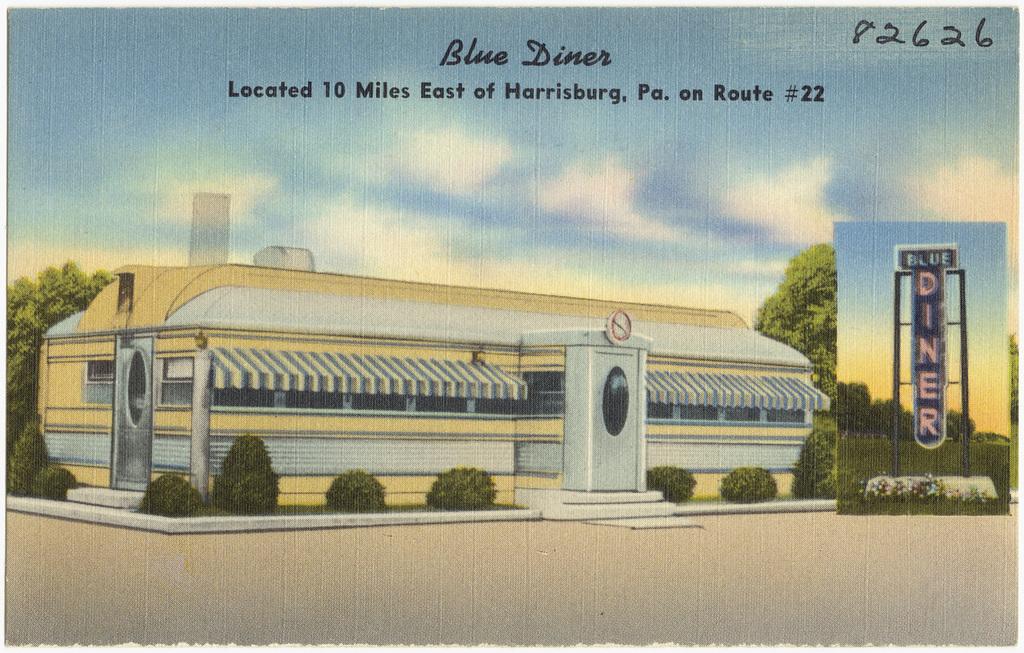This diner is how many miles from harrisburg, pa?
Ensure brevity in your answer.  10. What route is the diner on?
Provide a short and direct response. 22. 